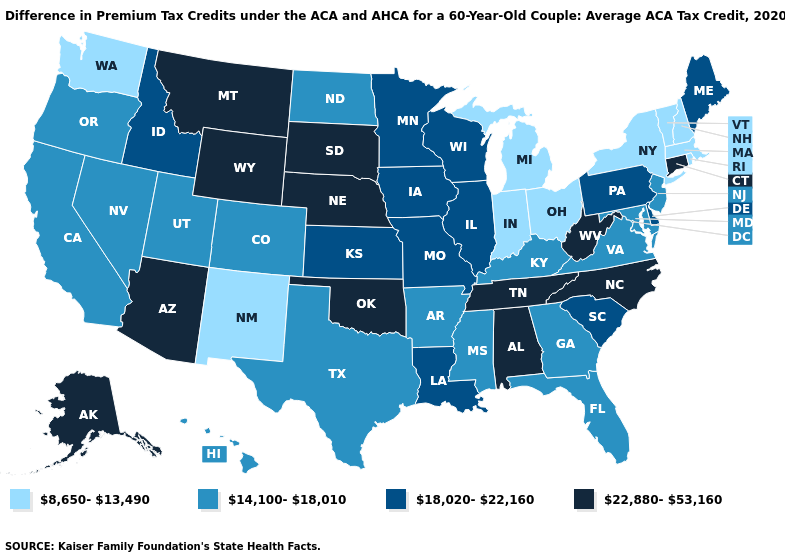Name the states that have a value in the range 8,650-13,490?
Write a very short answer. Indiana, Massachusetts, Michigan, New Hampshire, New Mexico, New York, Ohio, Rhode Island, Vermont, Washington. Does Georgia have a higher value than Michigan?
Concise answer only. Yes. Name the states that have a value in the range 18,020-22,160?
Short answer required. Delaware, Idaho, Illinois, Iowa, Kansas, Louisiana, Maine, Minnesota, Missouri, Pennsylvania, South Carolina, Wisconsin. What is the value of Virginia?
Be succinct. 14,100-18,010. Does Wisconsin have a lower value than Texas?
Quick response, please. No. Name the states that have a value in the range 14,100-18,010?
Give a very brief answer. Arkansas, California, Colorado, Florida, Georgia, Hawaii, Kentucky, Maryland, Mississippi, Nevada, New Jersey, North Dakota, Oregon, Texas, Utah, Virginia. What is the lowest value in states that border Washington?
Keep it brief. 14,100-18,010. Does Kentucky have a higher value than Arizona?
Write a very short answer. No. What is the value of Oregon?
Write a very short answer. 14,100-18,010. Which states have the lowest value in the MidWest?
Write a very short answer. Indiana, Michigan, Ohio. What is the lowest value in the MidWest?
Short answer required. 8,650-13,490. How many symbols are there in the legend?
Quick response, please. 4. Which states have the lowest value in the USA?
Give a very brief answer. Indiana, Massachusetts, Michigan, New Hampshire, New Mexico, New York, Ohio, Rhode Island, Vermont, Washington. Name the states that have a value in the range 22,880-53,160?
Give a very brief answer. Alabama, Alaska, Arizona, Connecticut, Montana, Nebraska, North Carolina, Oklahoma, South Dakota, Tennessee, West Virginia, Wyoming. Name the states that have a value in the range 8,650-13,490?
Quick response, please. Indiana, Massachusetts, Michigan, New Hampshire, New Mexico, New York, Ohio, Rhode Island, Vermont, Washington. 